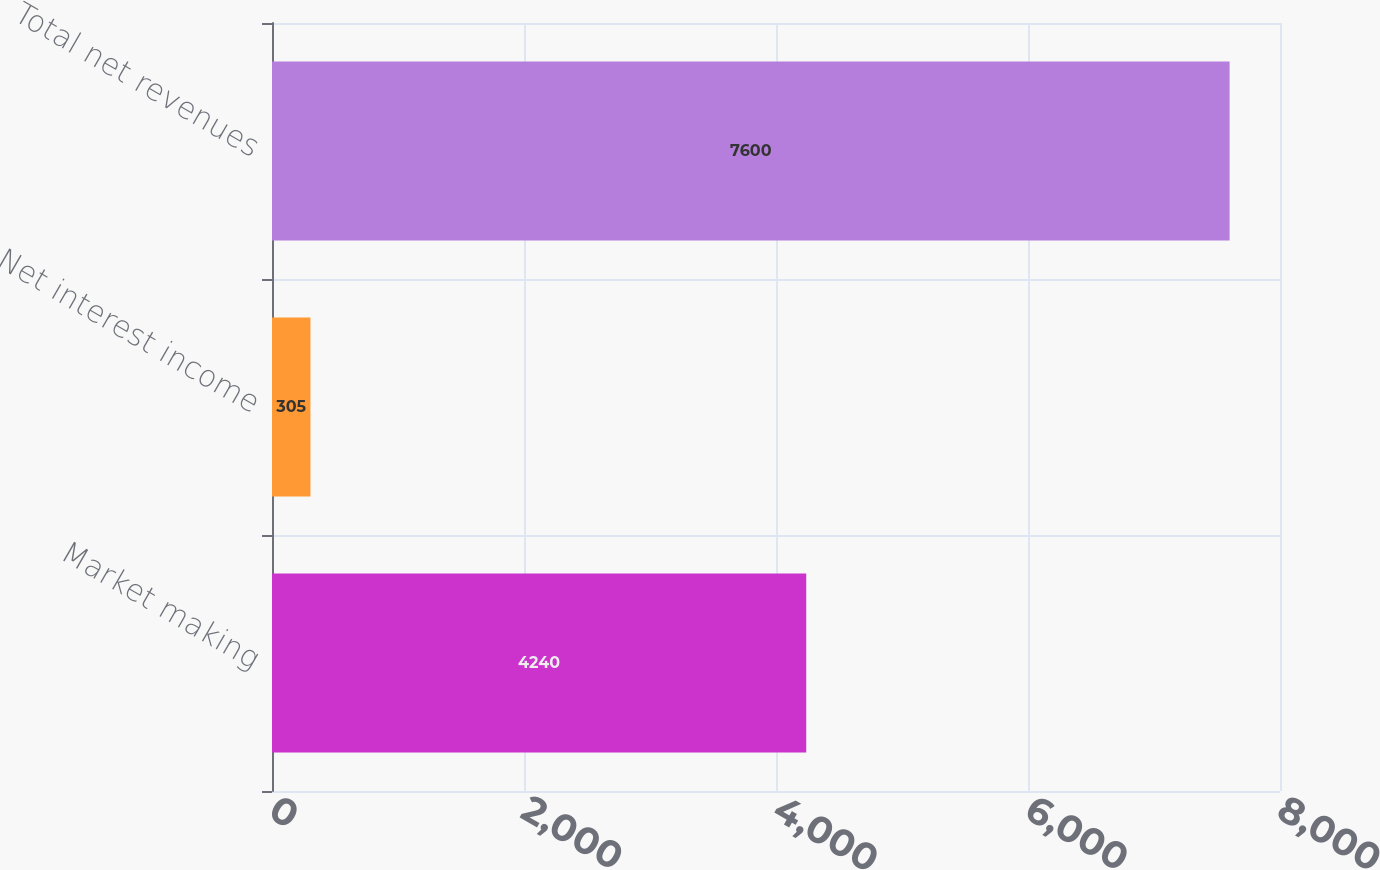<chart> <loc_0><loc_0><loc_500><loc_500><bar_chart><fcel>Market making<fcel>Net interest income<fcel>Total net revenues<nl><fcel>4240<fcel>305<fcel>7600<nl></chart> 